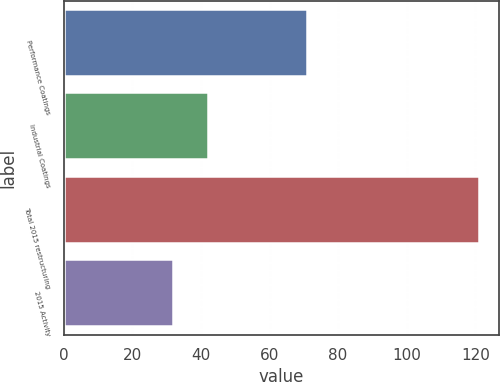<chart> <loc_0><loc_0><loc_500><loc_500><bar_chart><fcel>Performance Coatings<fcel>Industrial Coatings<fcel>Total 2015 restructuring<fcel>2015 Activity<nl><fcel>71<fcel>42<fcel>121<fcel>32<nl></chart> 